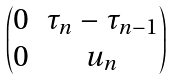<formula> <loc_0><loc_0><loc_500><loc_500>\begin{pmatrix} 0 & \tau _ { n } - \tau _ { n - 1 } \\ 0 & u _ { n } \end{pmatrix}</formula> 